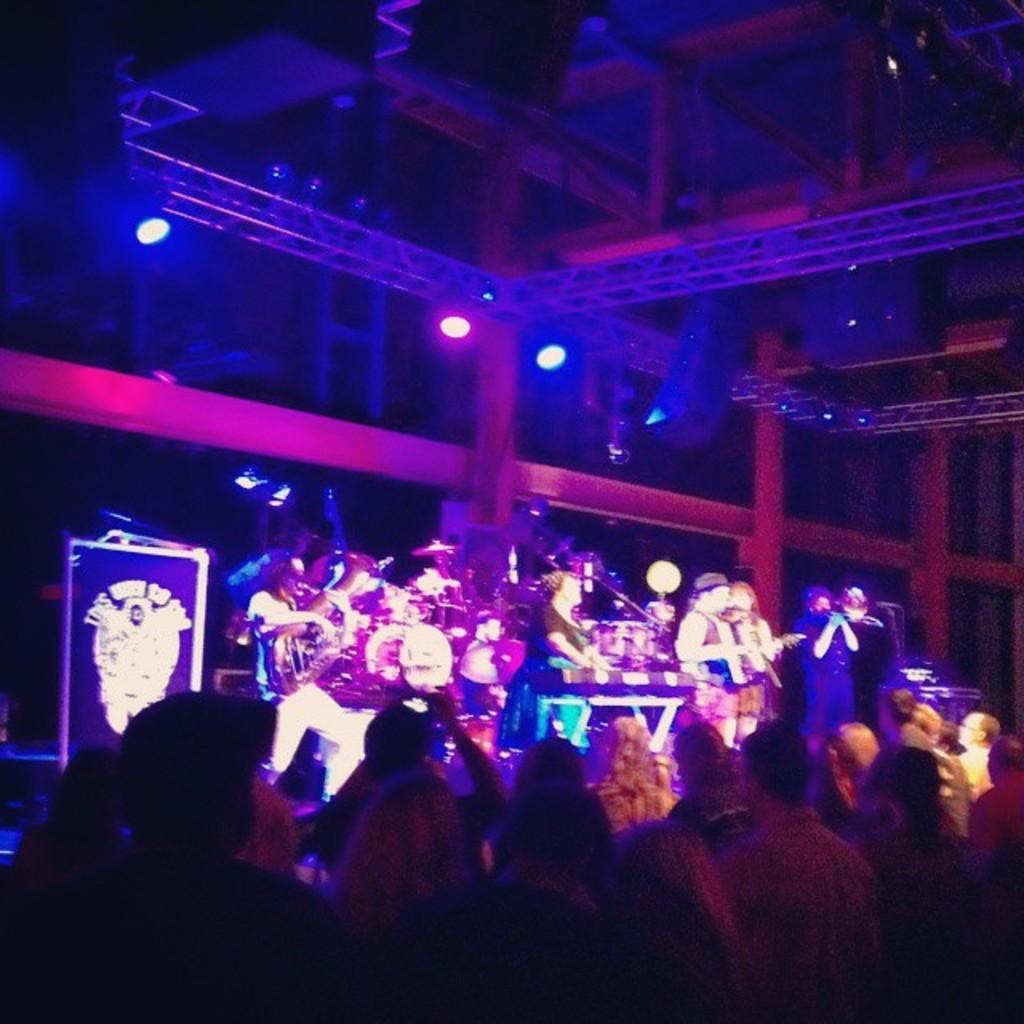In one or two sentences, can you explain what this image depicts? In the foreground of this image, on the bottom, there are persons standing and In the background, there are persons standing on the stage and playing musical instruments and also there is a board on the left and light in the middle to the pillar. 